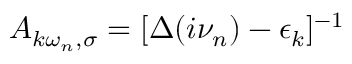<formula> <loc_0><loc_0><loc_500><loc_500>A _ { k \omega _ { n } , \sigma } = [ \Delta ( i \nu _ { n } ) - \epsilon _ { k } ] ^ { - 1 }</formula> 